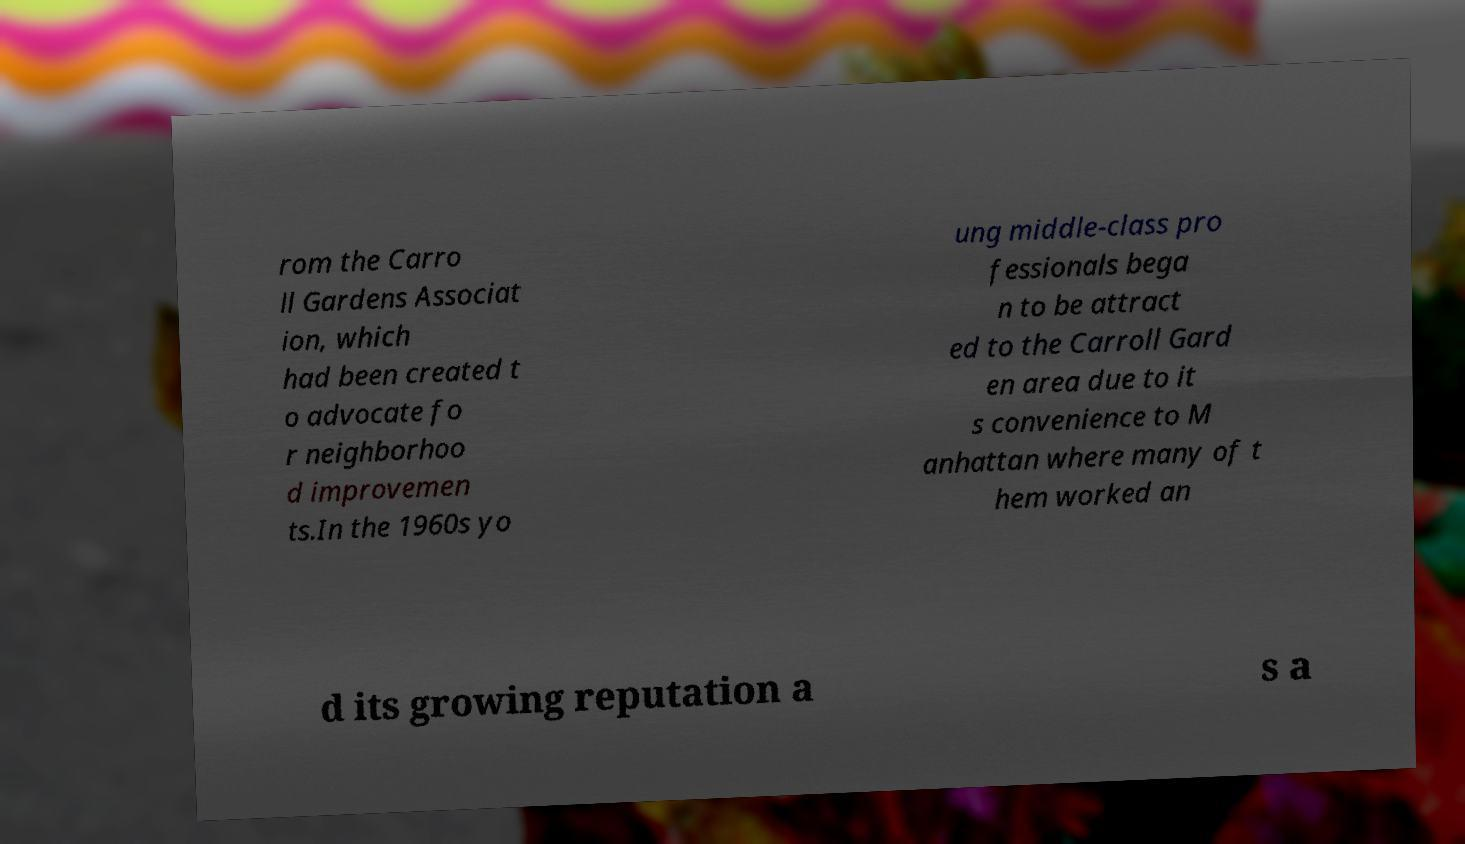There's text embedded in this image that I need extracted. Can you transcribe it verbatim? rom the Carro ll Gardens Associat ion, which had been created t o advocate fo r neighborhoo d improvemen ts.In the 1960s yo ung middle-class pro fessionals bega n to be attract ed to the Carroll Gard en area due to it s convenience to M anhattan where many of t hem worked an d its growing reputation a s a 